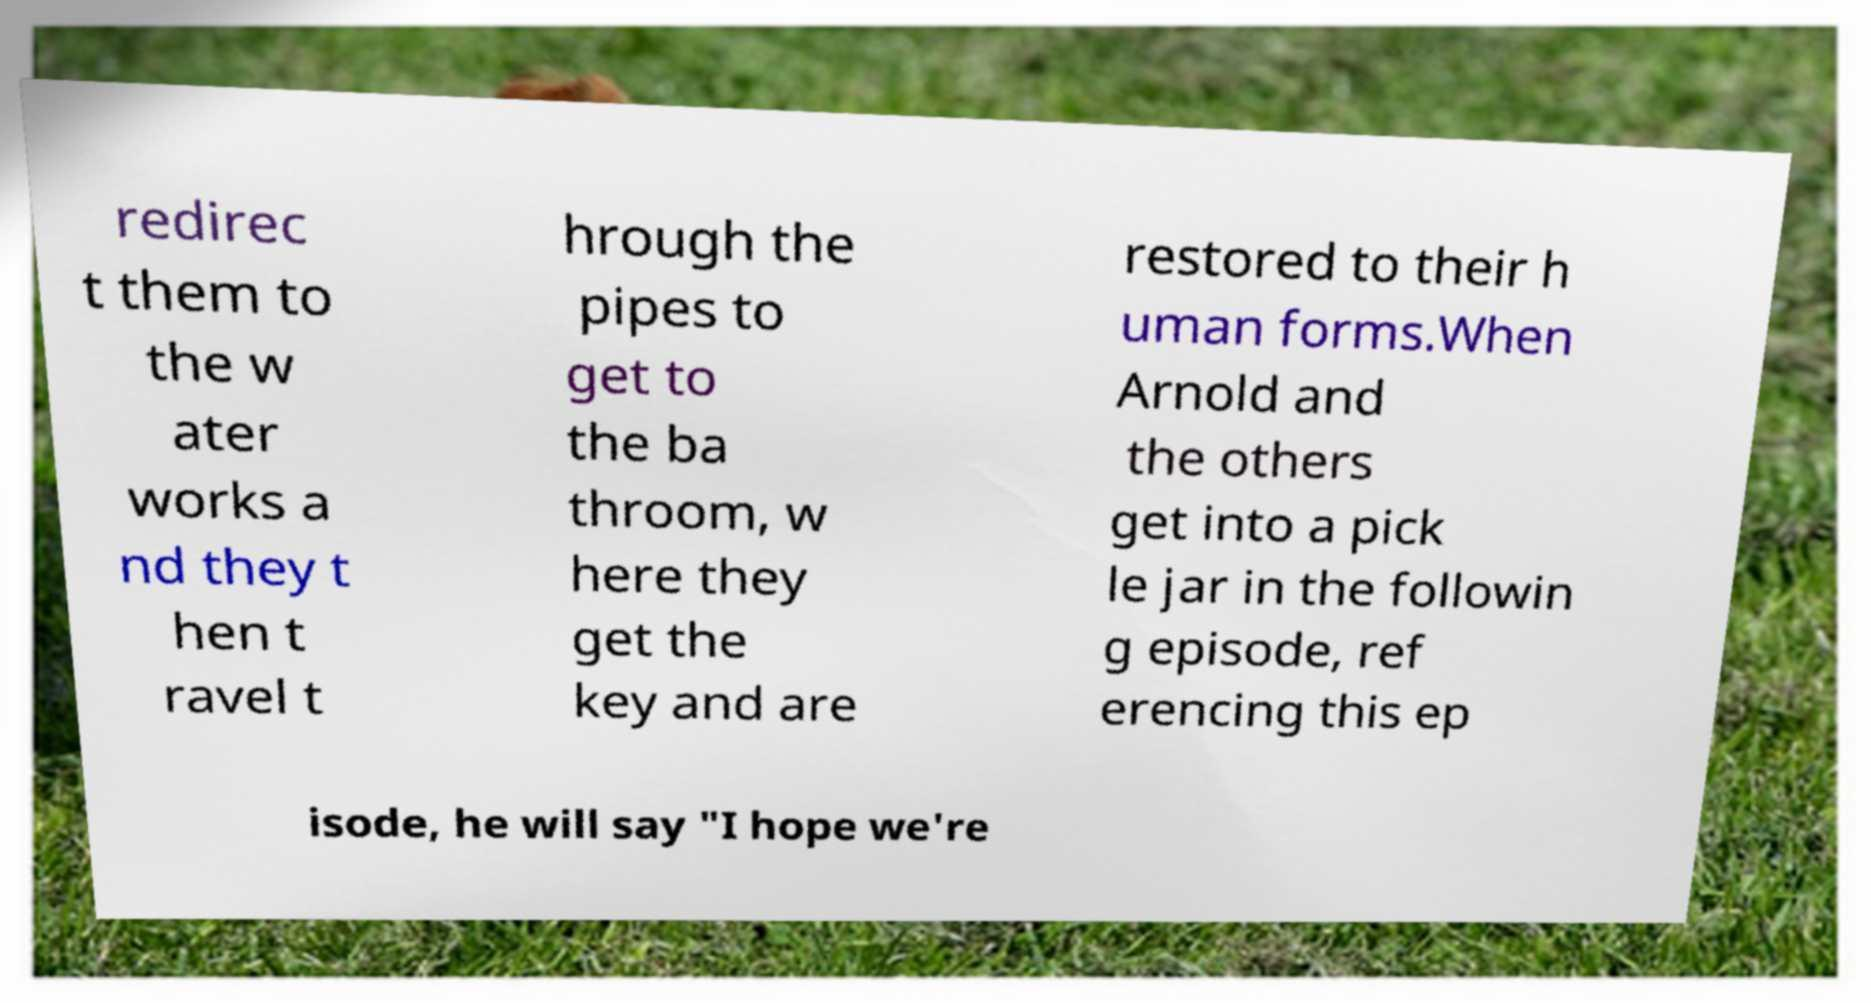Could you extract and type out the text from this image? redirec t them to the w ater works a nd they t hen t ravel t hrough the pipes to get to the ba throom, w here they get the key and are restored to their h uman forms.When Arnold and the others get into a pick le jar in the followin g episode, ref erencing this ep isode, he will say "I hope we're 